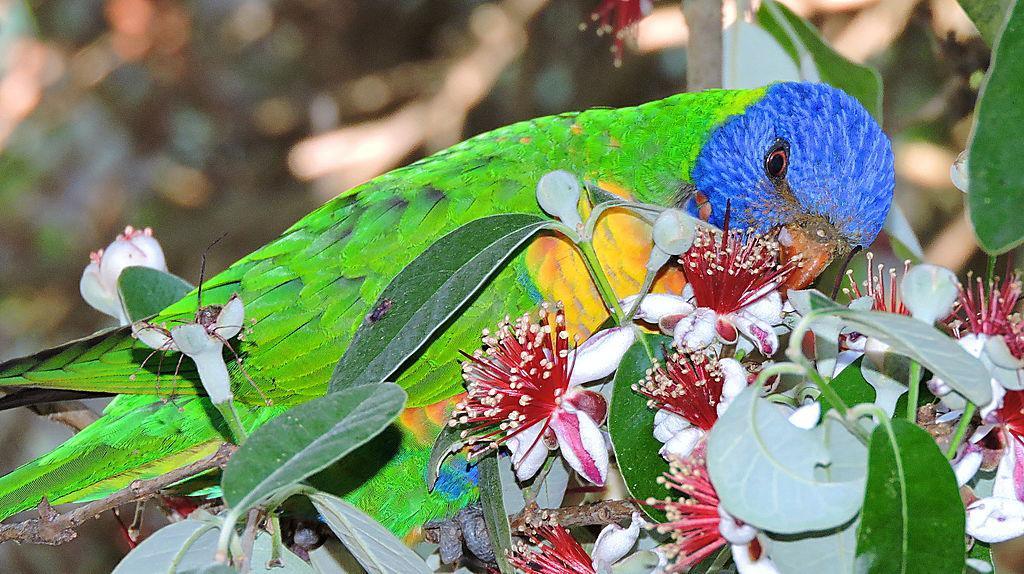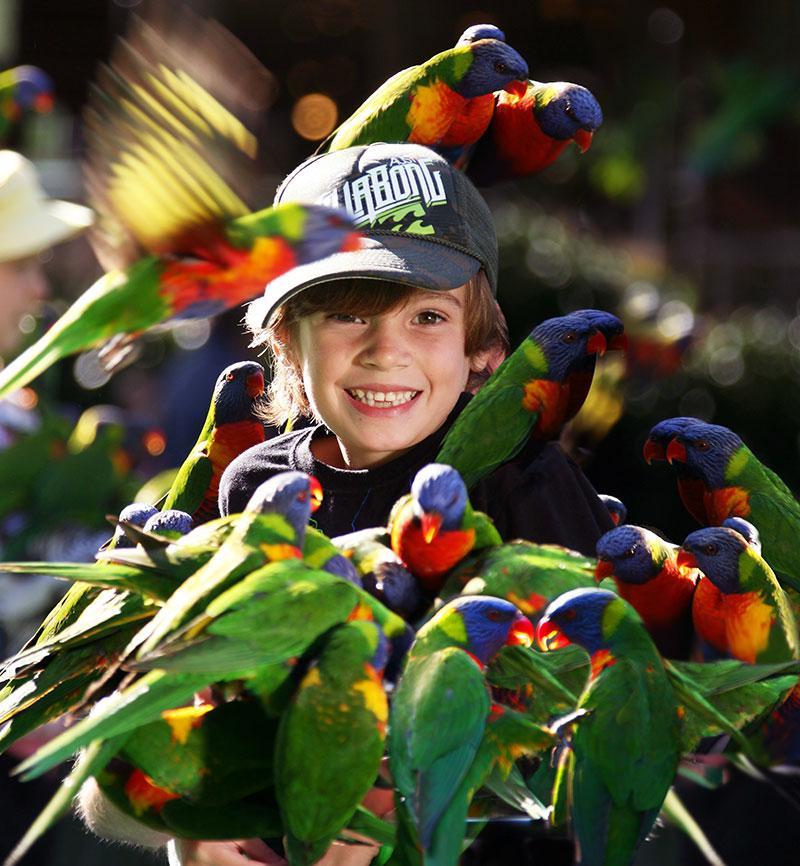The first image is the image on the left, the second image is the image on the right. Evaluate the accuracy of this statement regarding the images: "There is one human feeding birds in every image.". Is it true? Answer yes or no. No. The first image is the image on the left, the second image is the image on the right. Considering the images on both sides, is "Birds are perched on a male in the image on the right and at least one female in the image on the left." valid? Answer yes or no. No. 